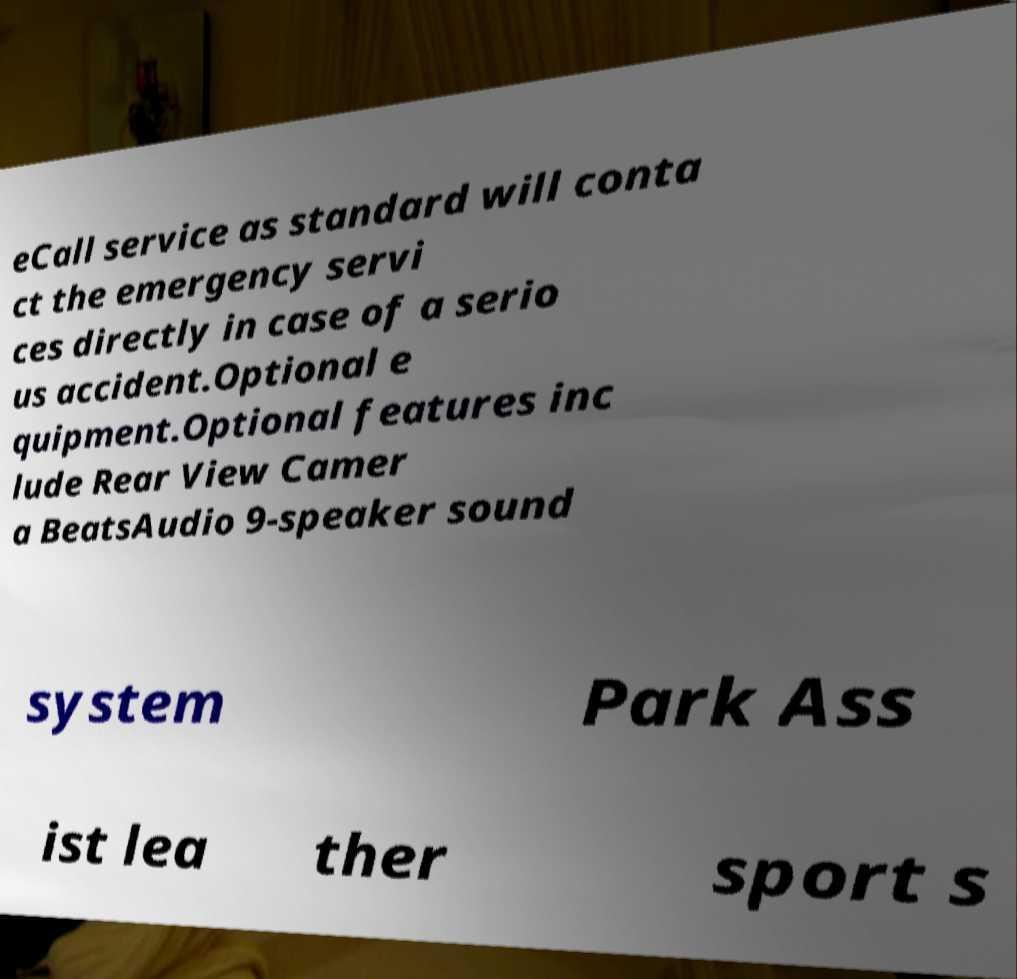Can you read and provide the text displayed in the image?This photo seems to have some interesting text. Can you extract and type it out for me? eCall service as standard will conta ct the emergency servi ces directly in case of a serio us accident.Optional e quipment.Optional features inc lude Rear View Camer a BeatsAudio 9-speaker sound system Park Ass ist lea ther sport s 